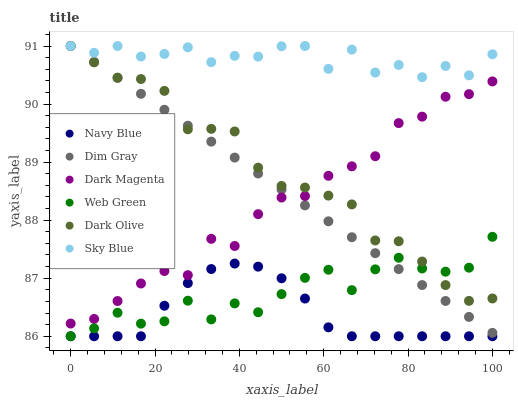Does Navy Blue have the minimum area under the curve?
Answer yes or no. Yes. Does Sky Blue have the maximum area under the curve?
Answer yes or no. Yes. Does Dark Magenta have the minimum area under the curve?
Answer yes or no. No. Does Dark Magenta have the maximum area under the curve?
Answer yes or no. No. Is Dim Gray the smoothest?
Answer yes or no. Yes. Is Sky Blue the roughest?
Answer yes or no. Yes. Is Dark Magenta the smoothest?
Answer yes or no. No. Is Dark Magenta the roughest?
Answer yes or no. No. Does Navy Blue have the lowest value?
Answer yes or no. Yes. Does Dark Magenta have the lowest value?
Answer yes or no. No. Does Sky Blue have the highest value?
Answer yes or no. Yes. Does Dark Magenta have the highest value?
Answer yes or no. No. Is Navy Blue less than Dark Olive?
Answer yes or no. Yes. Is Dark Magenta greater than Navy Blue?
Answer yes or no. Yes. Does Sky Blue intersect Dim Gray?
Answer yes or no. Yes. Is Sky Blue less than Dim Gray?
Answer yes or no. No. Is Sky Blue greater than Dim Gray?
Answer yes or no. No. Does Navy Blue intersect Dark Olive?
Answer yes or no. No. 